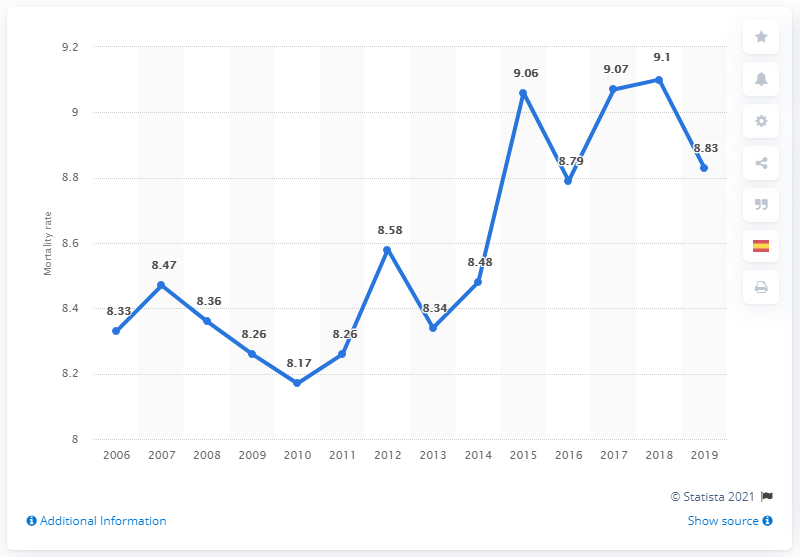Specify some key components in this picture. In 2006, the mortality rate in Spain was 8.33 deaths per 1,000 people. The average mortality rate in Spain from 2017 to 2019 was 9.. The mortality rate in Spain in 2019 was 8.83%. 